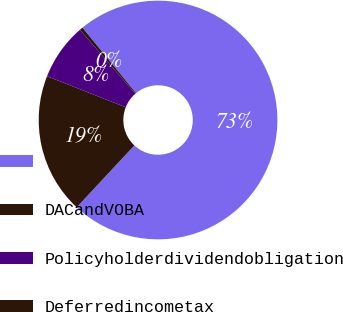Convert chart to OTSL. <chart><loc_0><loc_0><loc_500><loc_500><pie_chart><ecel><fcel>DACandVOBA<fcel>Policyholderdividendobligation<fcel>Deferredincometax<nl><fcel>72.86%<fcel>19.04%<fcel>7.67%<fcel>0.43%<nl></chart> 